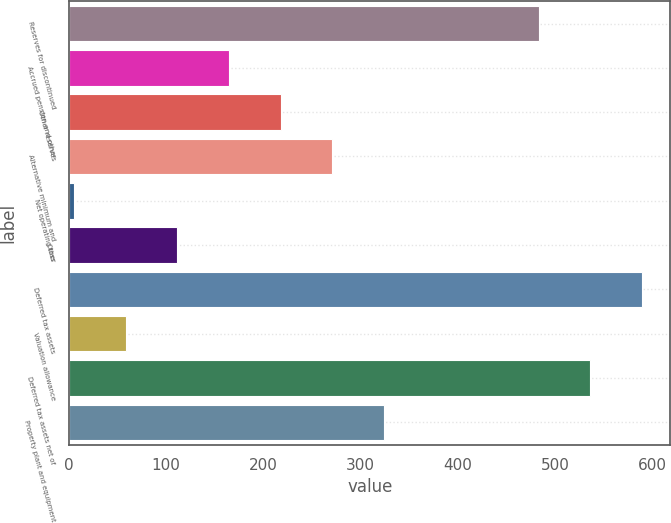Convert chart. <chart><loc_0><loc_0><loc_500><loc_500><bar_chart><fcel>Reserves for discontinued<fcel>Accrued pension and other<fcel>Other reserves<fcel>Alternative minimum and<fcel>Net operating loss<fcel>Other<fcel>Deferred tax assets<fcel>Valuation allowance<fcel>Deferred tax assets net of<fcel>Property plant and equipment<nl><fcel>482.84<fcel>164.48<fcel>217.54<fcel>270.6<fcel>5.3<fcel>111.42<fcel>588.96<fcel>58.36<fcel>535.9<fcel>323.66<nl></chart> 